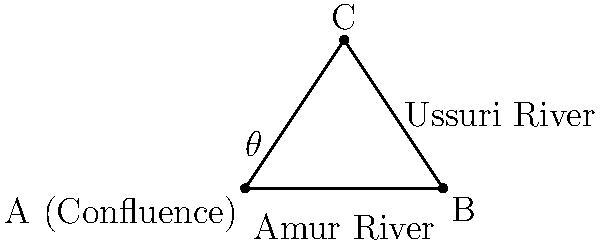In your research of the Russian Far East, you come across an interesting geographical feature: the confluence of the Amur and Ussuri rivers. The Amur River flows eastward, while the Ussuri River joins it from the south. If the angle between these rivers at their confluence is $\theta$, and the distance from the confluence to a point directly north of it on the Ussuri River is 3 km, while the distance from this point to where it meets the Amur River is 4 km, what is the value of $\theta$ in degrees? Let's approach this step-by-step:

1) The scenario describes a right-angled triangle, where:
   - The confluence point is A
   - The point directly north on the Ussuri River is C
   - The point where the perpendicular from C meets the Amur River is B

2) We know:
   - AC (along the Ussuri River) = 3 km
   - BC (perpendicular to the Amur River) = 4 km
   - Angle CAB is our target angle $\theta$

3) This forms a right-angled triangle where we know the two sides adjacent to the right angle.

4) To find $\theta$, we can use the arctangent function:

   $\theta = \arctan(\frac{\text{opposite}}{\text{adjacent}}) = \arctan(\frac{BC}{AB})$

5) $\theta = \arctan(\frac{4}{3})$

6) Using a calculator or mathematical tables:
   $\theta \approx 53.13$ degrees

7) Rounding to the nearest degree:
   $\theta \approx 53°$

This angle represents the approximate direction change a boat would experience when moving from the Amur River into the Ussuri River at their confluence.
Answer: 53° 